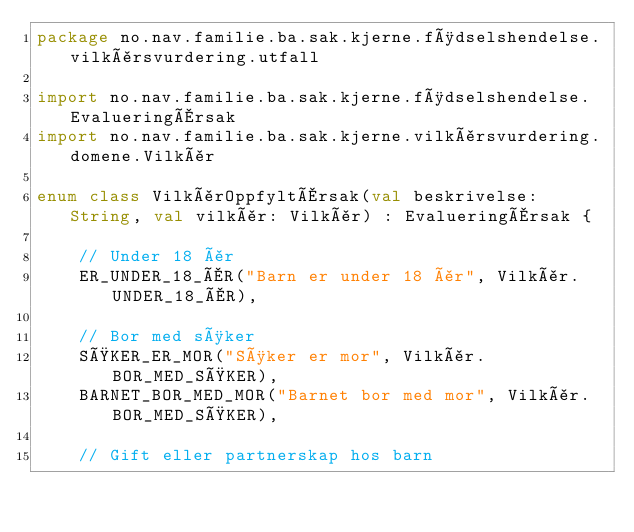Convert code to text. <code><loc_0><loc_0><loc_500><loc_500><_Kotlin_>package no.nav.familie.ba.sak.kjerne.fødselshendelse.vilkårsvurdering.utfall

import no.nav.familie.ba.sak.kjerne.fødselshendelse.EvalueringÅrsak
import no.nav.familie.ba.sak.kjerne.vilkårsvurdering.domene.Vilkår

enum class VilkårOppfyltÅrsak(val beskrivelse: String, val vilkår: Vilkår) : EvalueringÅrsak {

    // Under 18 år
    ER_UNDER_18_ÅR("Barn er under 18 år", Vilkår.UNDER_18_ÅR),

    // Bor med søker
    SØKER_ER_MOR("Søker er mor", Vilkår.BOR_MED_SØKER),
    BARNET_BOR_MED_MOR("Barnet bor med mor", Vilkår.BOR_MED_SØKER),

    // Gift eller partnerskap hos barn</code> 